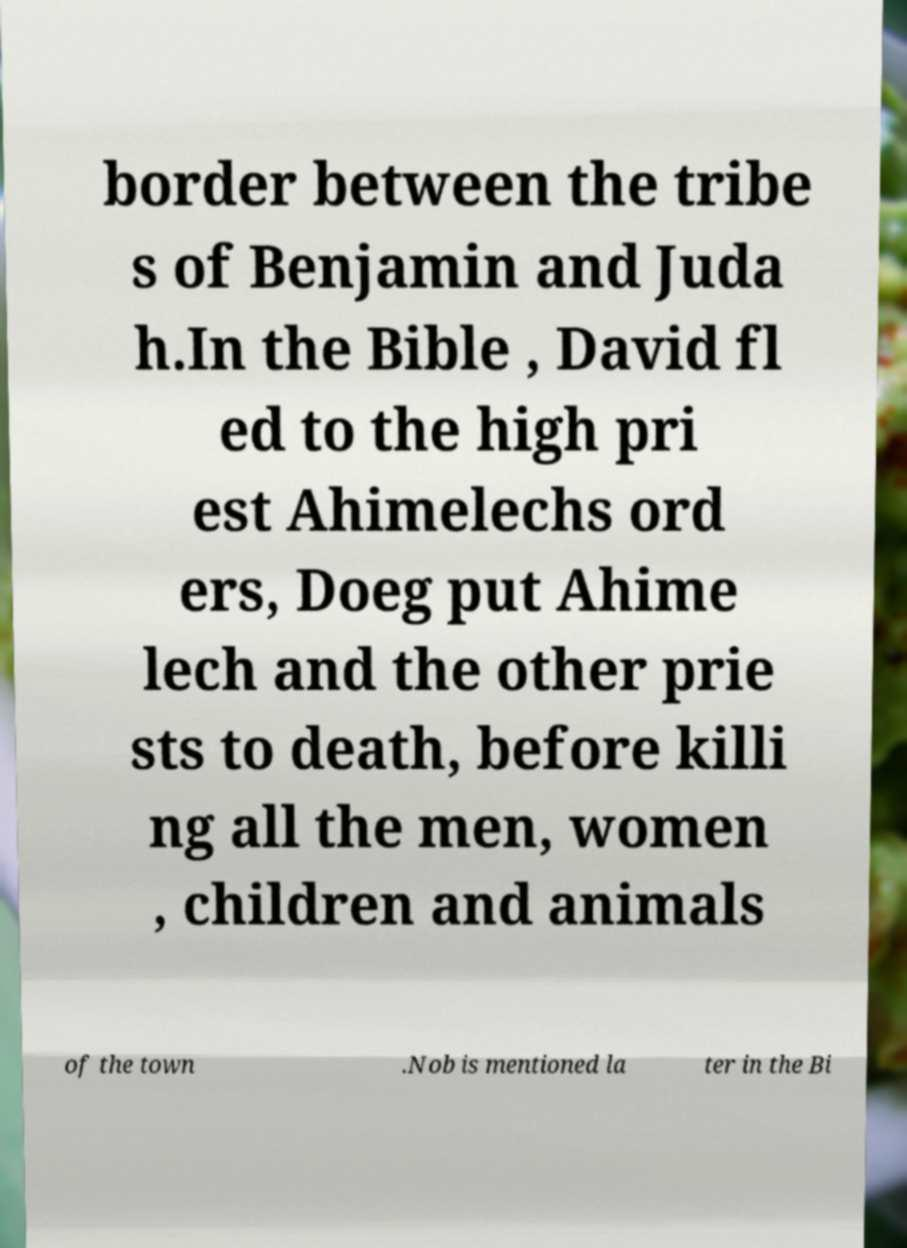Can you read and provide the text displayed in the image?This photo seems to have some interesting text. Can you extract and type it out for me? border between the tribe s of Benjamin and Juda h.In the Bible , David fl ed to the high pri est Ahimelechs ord ers, Doeg put Ahime lech and the other prie sts to death, before killi ng all the men, women , children and animals of the town .Nob is mentioned la ter in the Bi 